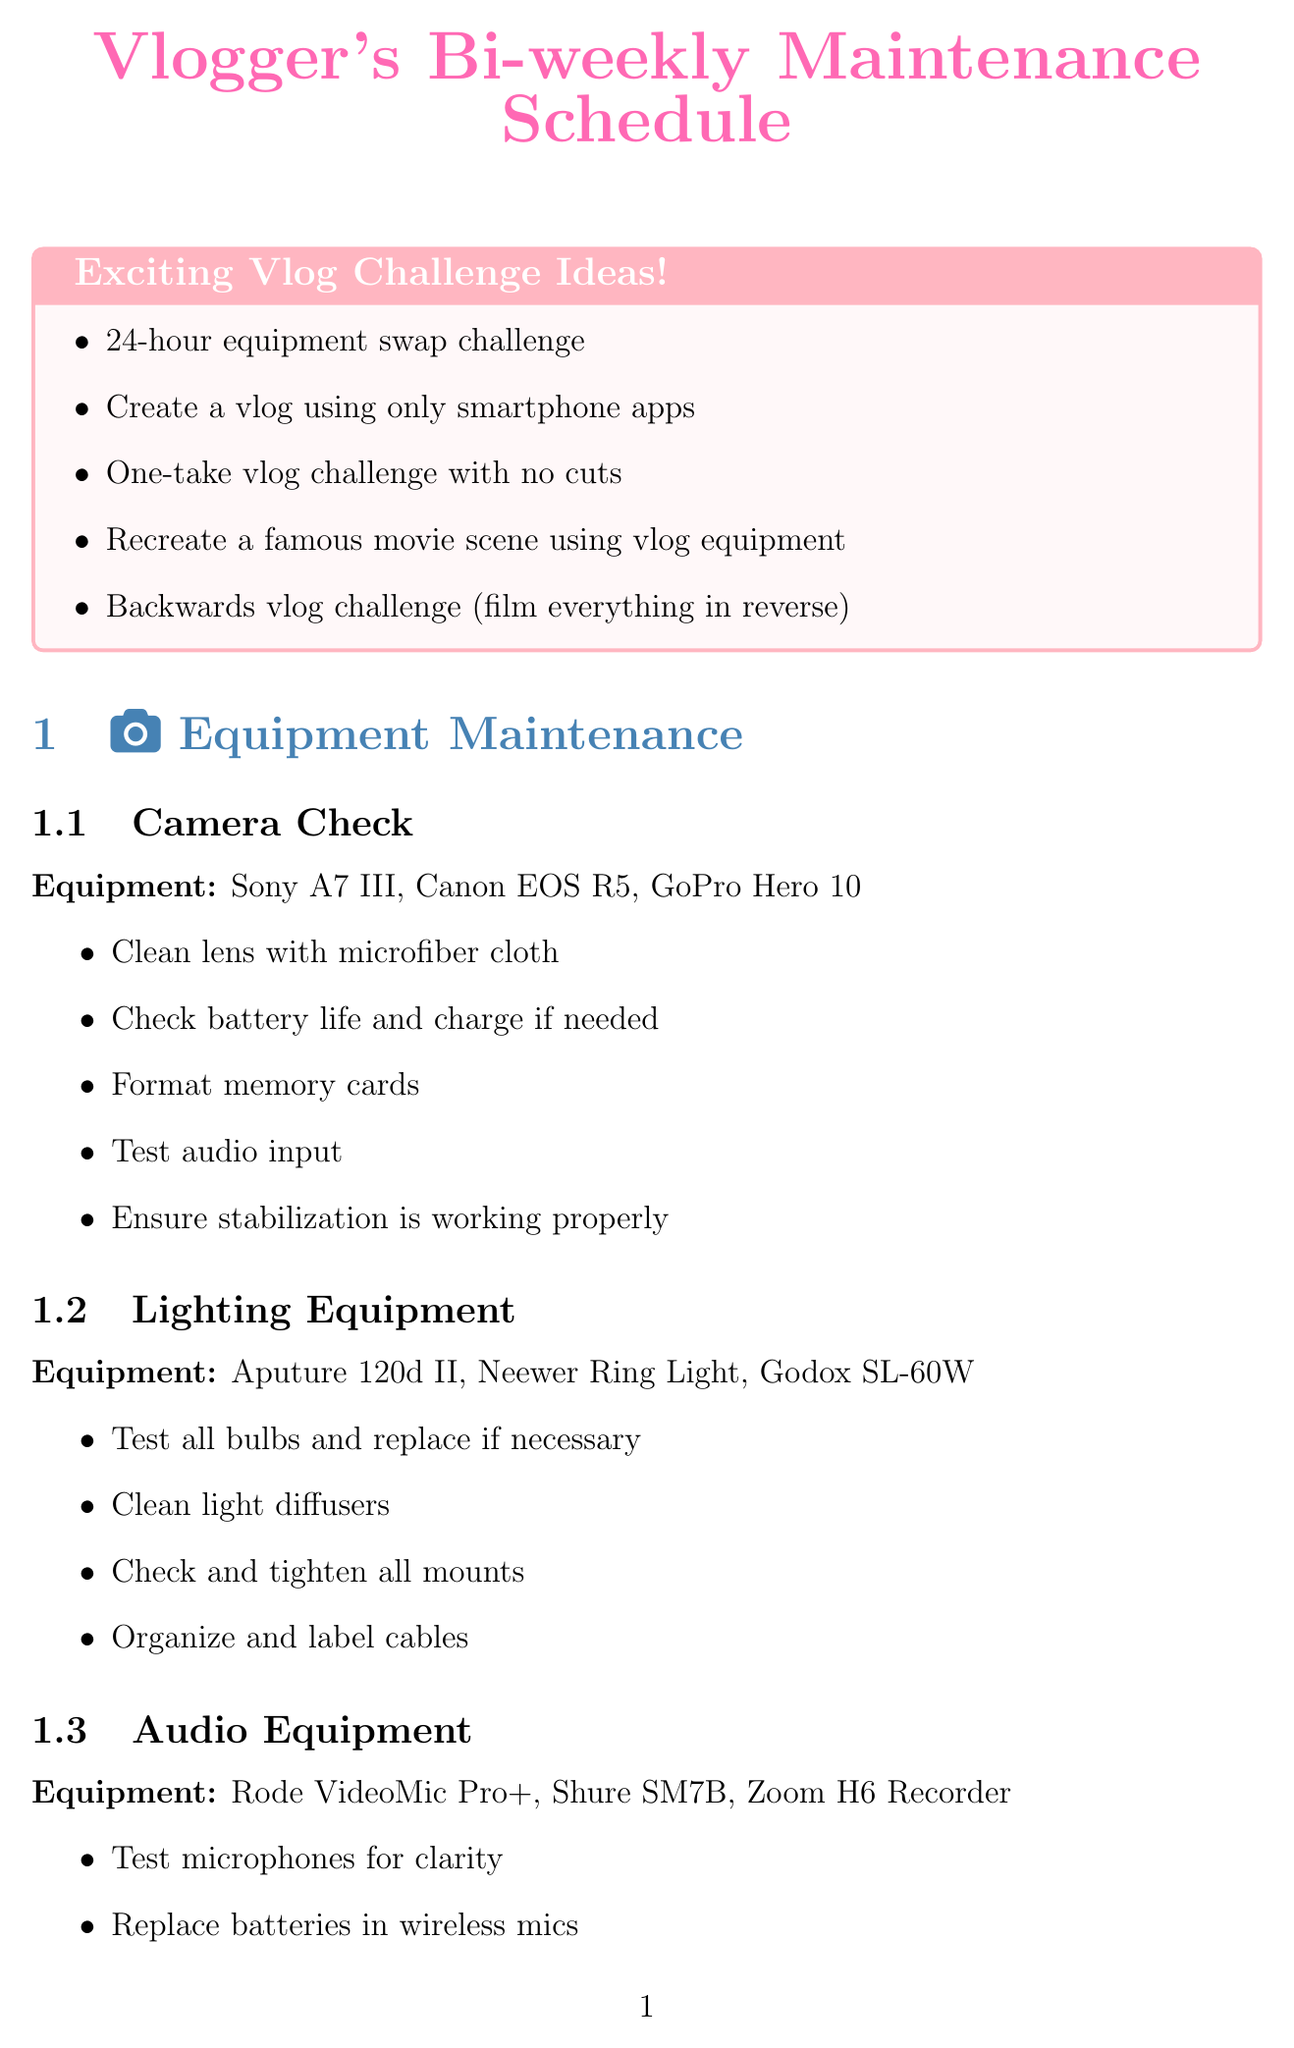What is one of the editing software mentioned? The document lists various editing software as part of the software updates section. One of them is Adobe Premiere Pro.
Answer: Adobe Premiere Pro How many tasks are listed for audio equipment maintenance? The audio equipment maintenance section includes four specific tasks.
Answer: Four What color is used for section headings in the document? The section headings are specified to use a particular color in the LaTeX document, described as RGB color code. The color used is defined as sectioncolor.
Answer: RGB (70,130,180) Which equipment needs to be lubricated according to the maintenance schedule? The document specifies that lubricating moving parts is a task associated with tripods and gimbals.
Answer: Tripods and Gimbals How many ideas are listed for exciting vlog challenges? The document includes a list of exciting vlog challenge ideas, totaling ten suggestions.
Answer: Ten What is the last software category mentioned in the software updates section? The software updates section lists categories, and the last one mentioned is streaming and recording.
Answer: Streaming and Recording Which task involves checking cable connections? Among the audio equipment maintenance tasks, one task is checking cable connections.
Answer: Checking cable connections Name a vlog challenge that involves creating a visual story without talking. The document mentions a silent vlog challenge where no talking is involved, only visuals and text.
Answer: Silent vlog challenge 